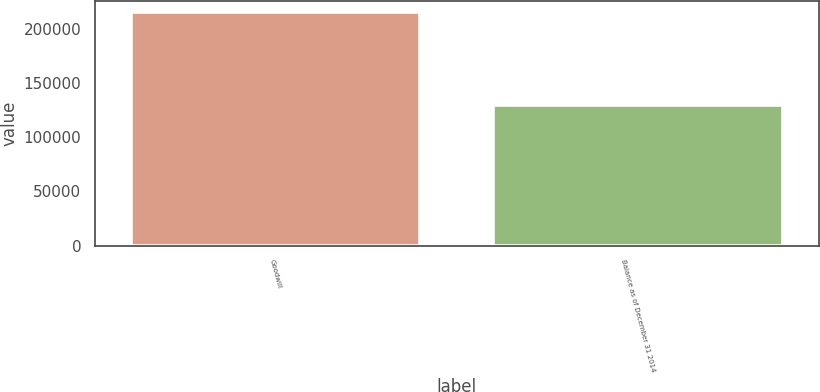Convert chart to OTSL. <chart><loc_0><loc_0><loc_500><loc_500><bar_chart><fcel>Goodwill<fcel>Balance as of December 31 2014<nl><fcel>214898<fcel>129898<nl></chart> 